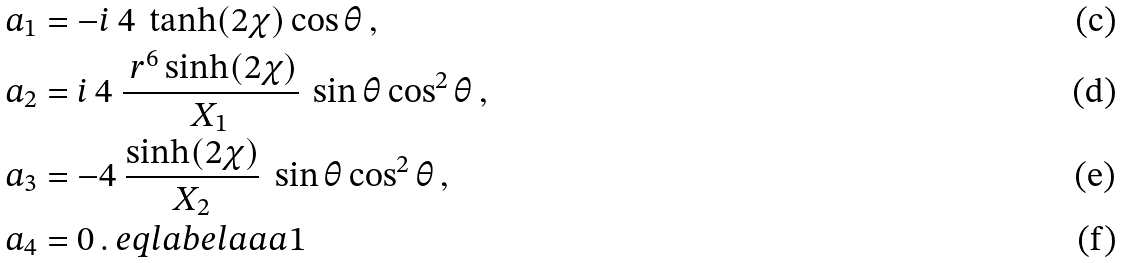<formula> <loc_0><loc_0><loc_500><loc_500>a _ { 1 } & = - i \ 4 \ \tanh ( 2 \chi ) \cos \theta \, , \\ a _ { 2 } & = i \ 4 \ \frac { \ r ^ { 6 } \sinh ( 2 \chi ) } { X _ { 1 } } \ \sin \theta \cos ^ { 2 } \theta \, , \\ a _ { 3 } & = - 4 \ \frac { \sinh ( 2 \chi ) } { X _ { 2 } } \ \sin \theta \cos ^ { 2 } \theta \, , \\ a _ { 4 } & = 0 \, . \ e q l a b e l { a a a 1 }</formula> 